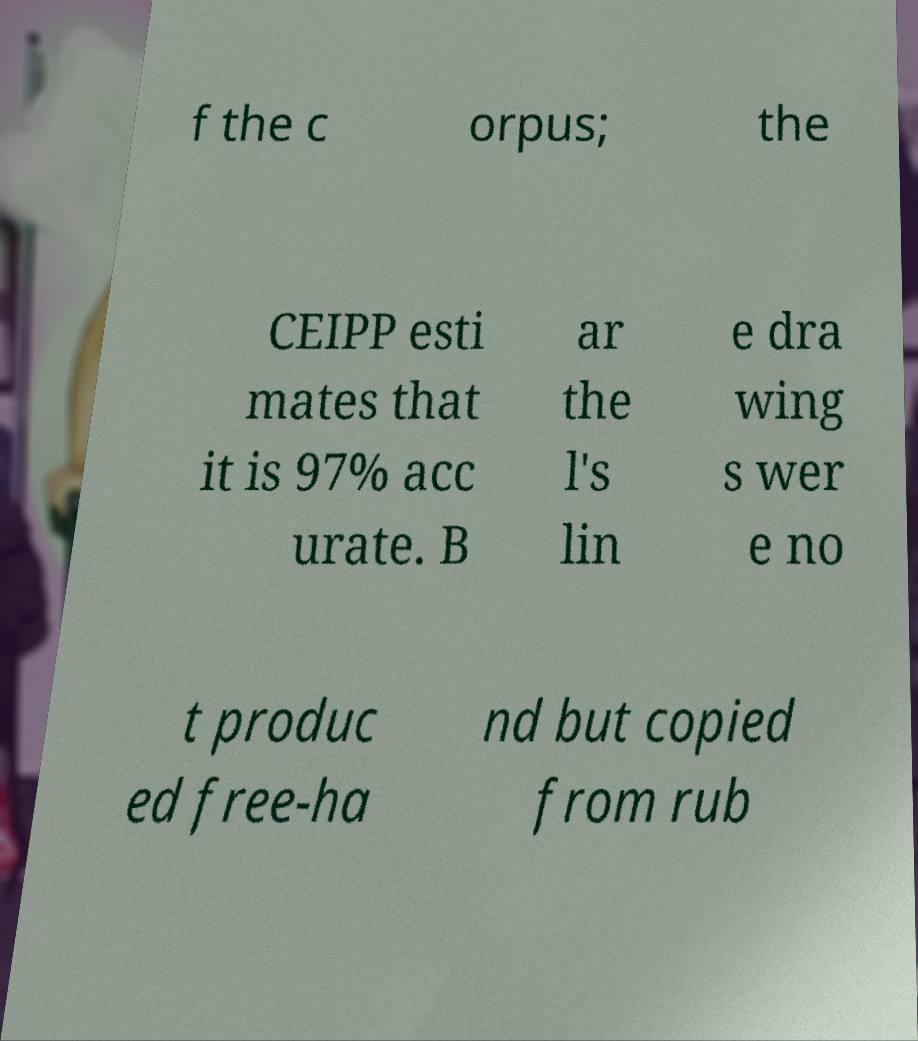Please read and relay the text visible in this image. What does it say? f the c orpus; the CEIPP esti mates that it is 97% acc urate. B ar the l's lin e dra wing s wer e no t produc ed free-ha nd but copied from rub 